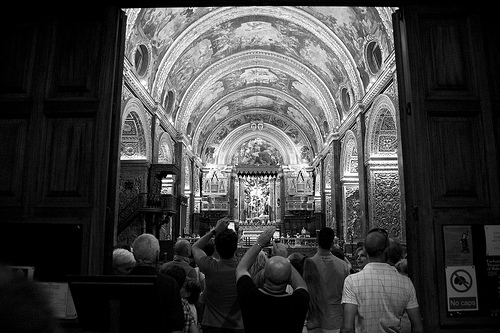What types of events could be hosted in this church? This church could host various events such as traditional religious ceremonies, weddings, christenings, community gatherings, and perhaps even classical music concerts due to its likely rich acoustics. 